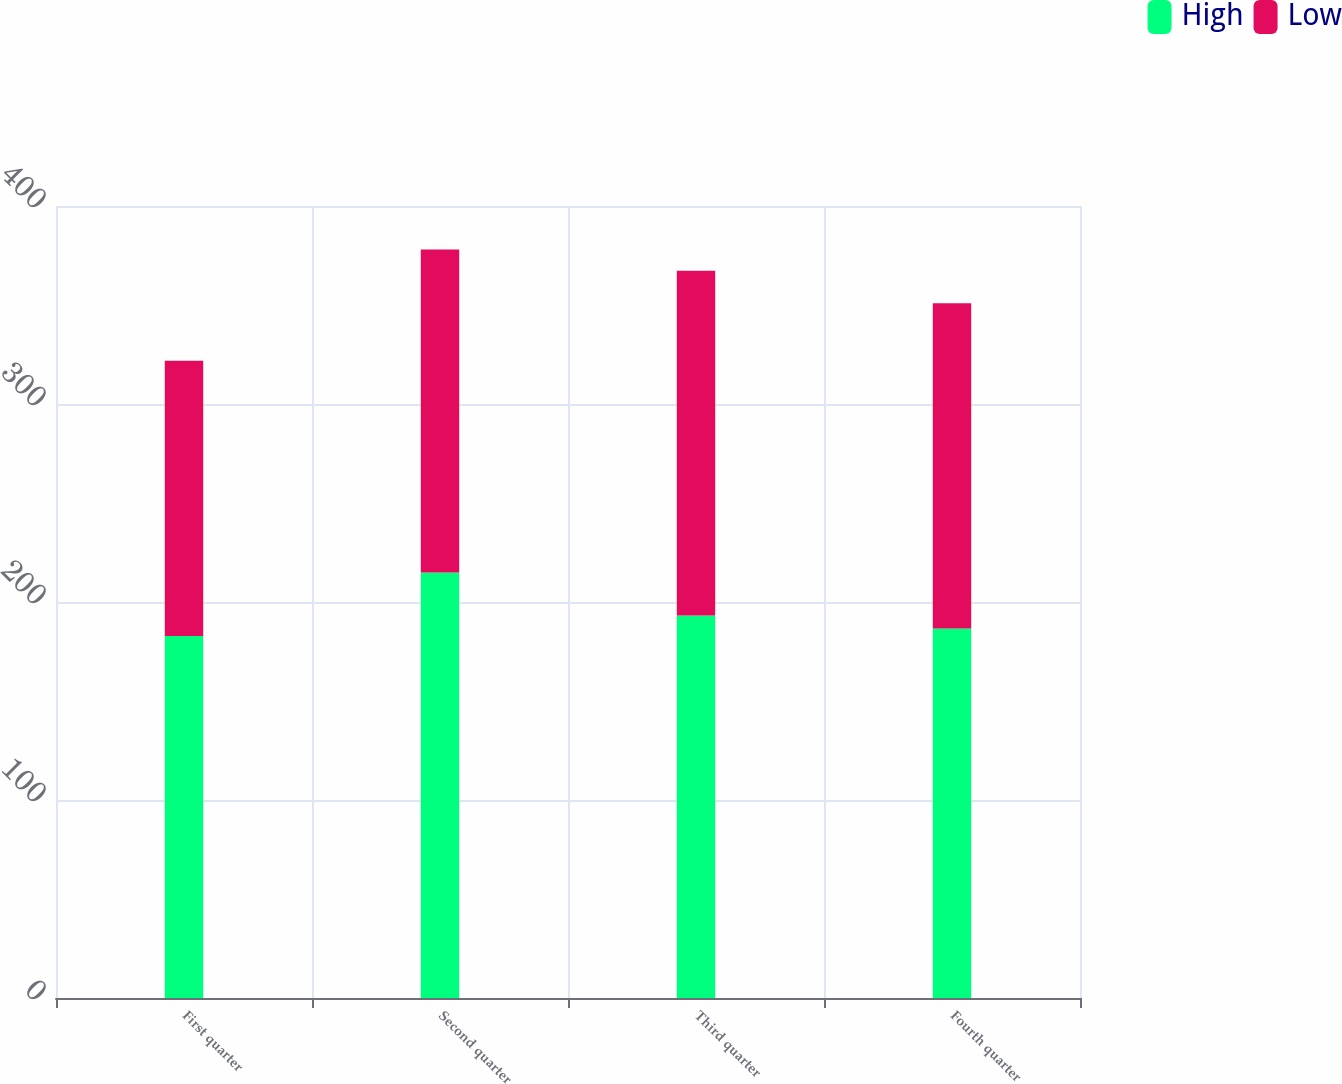Convert chart. <chart><loc_0><loc_0><loc_500><loc_500><stacked_bar_chart><ecel><fcel>First quarter<fcel>Second quarter<fcel>Third quarter<fcel>Fourth quarter<nl><fcel>High<fcel>182.79<fcel>214.92<fcel>193.14<fcel>186.67<nl><fcel>Low<fcel>139.09<fcel>163.07<fcel>174.16<fcel>164.25<nl></chart> 